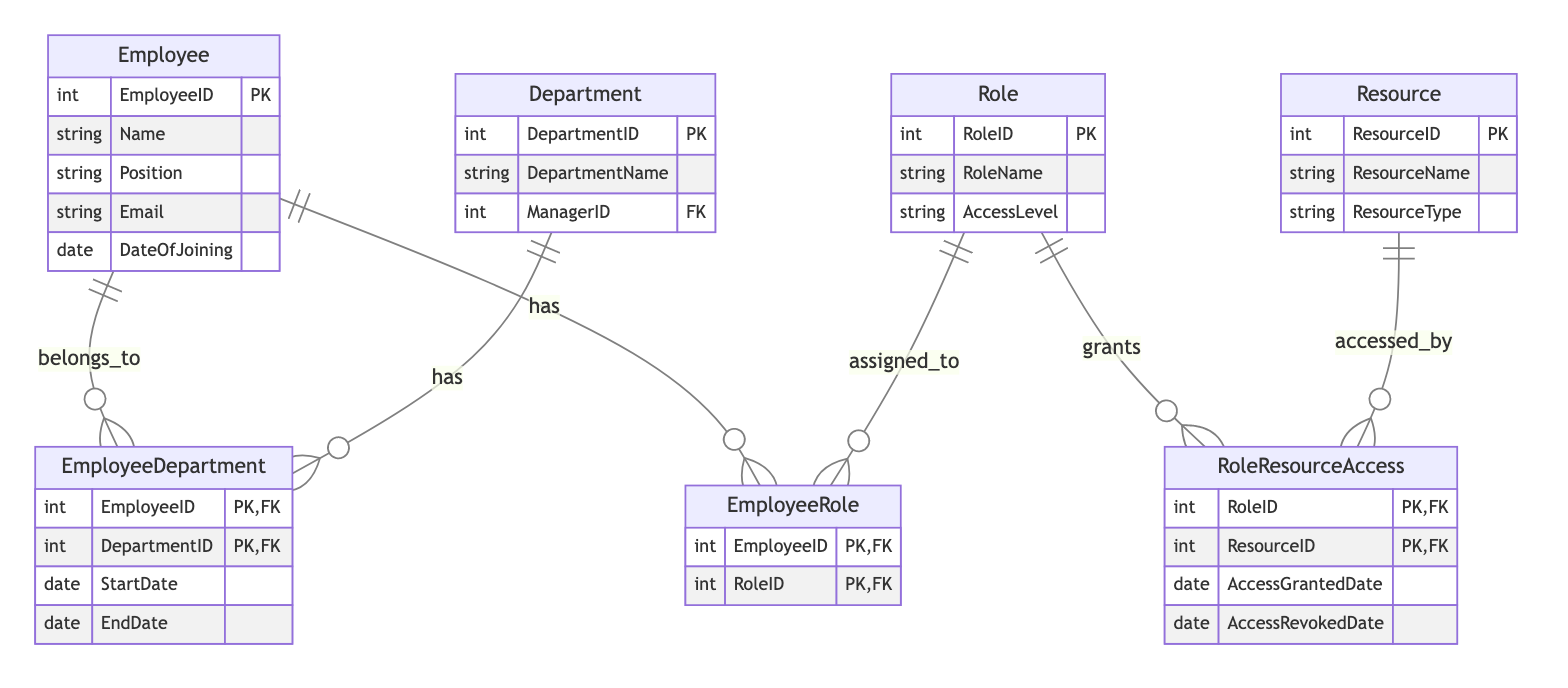What is the primary key of the Employee entity? The Employee entity has a primary key denoted with "PK," which is the "EmployeeID."
Answer: EmployeeID How many attributes are there in the Role entity? The Role entity contains three attributes: "RoleID," "RoleName," and "AccessLevel."
Answer: 3 Which entity has the relationship "belongs_to"? The "EmployeeDepartment" relationship indicates that the Employee entity "belongs_to" the Department entity.
Answer: Employee What is the foreign key in the EmployeeDepartment relationship? The foreign keys in the EmployeeDepartment relationship are "EmployeeID" and "DepartmentID," which refer to the Employee and Department entities respectively.
Answer: EmployeeID, DepartmentID Which entity can be accessed by the Role? The Role entity grants access to the Resource entity as indicated by the "RoleResourceAccess" relationship.
Answer: Resource What is the mandatory attribute of the Resource entity? The Resource entity must have "ResourceID" as its mandatory attribute since it acts as the primary key.
Answer: ResourceID How many relationships are there connecting the Employee entity? The Employee entity connects through two relationships: "EmployeeDepartment" and "EmployeeRole."
Answer: 2 What is the AccessLevel attribute in the Role entity? The AccessLevel attribute specifies the level of access that the Role provides, which can vary based on the specific role assigned within the organization.
Answer: AccessLevel What attribute denotes the date when access was granted in RoleResourceAccess? The "AccessGrantedDate" attribute represents the date when access is granted in the RoleResourceAccess relationship.
Answer: AccessGrantedDate 